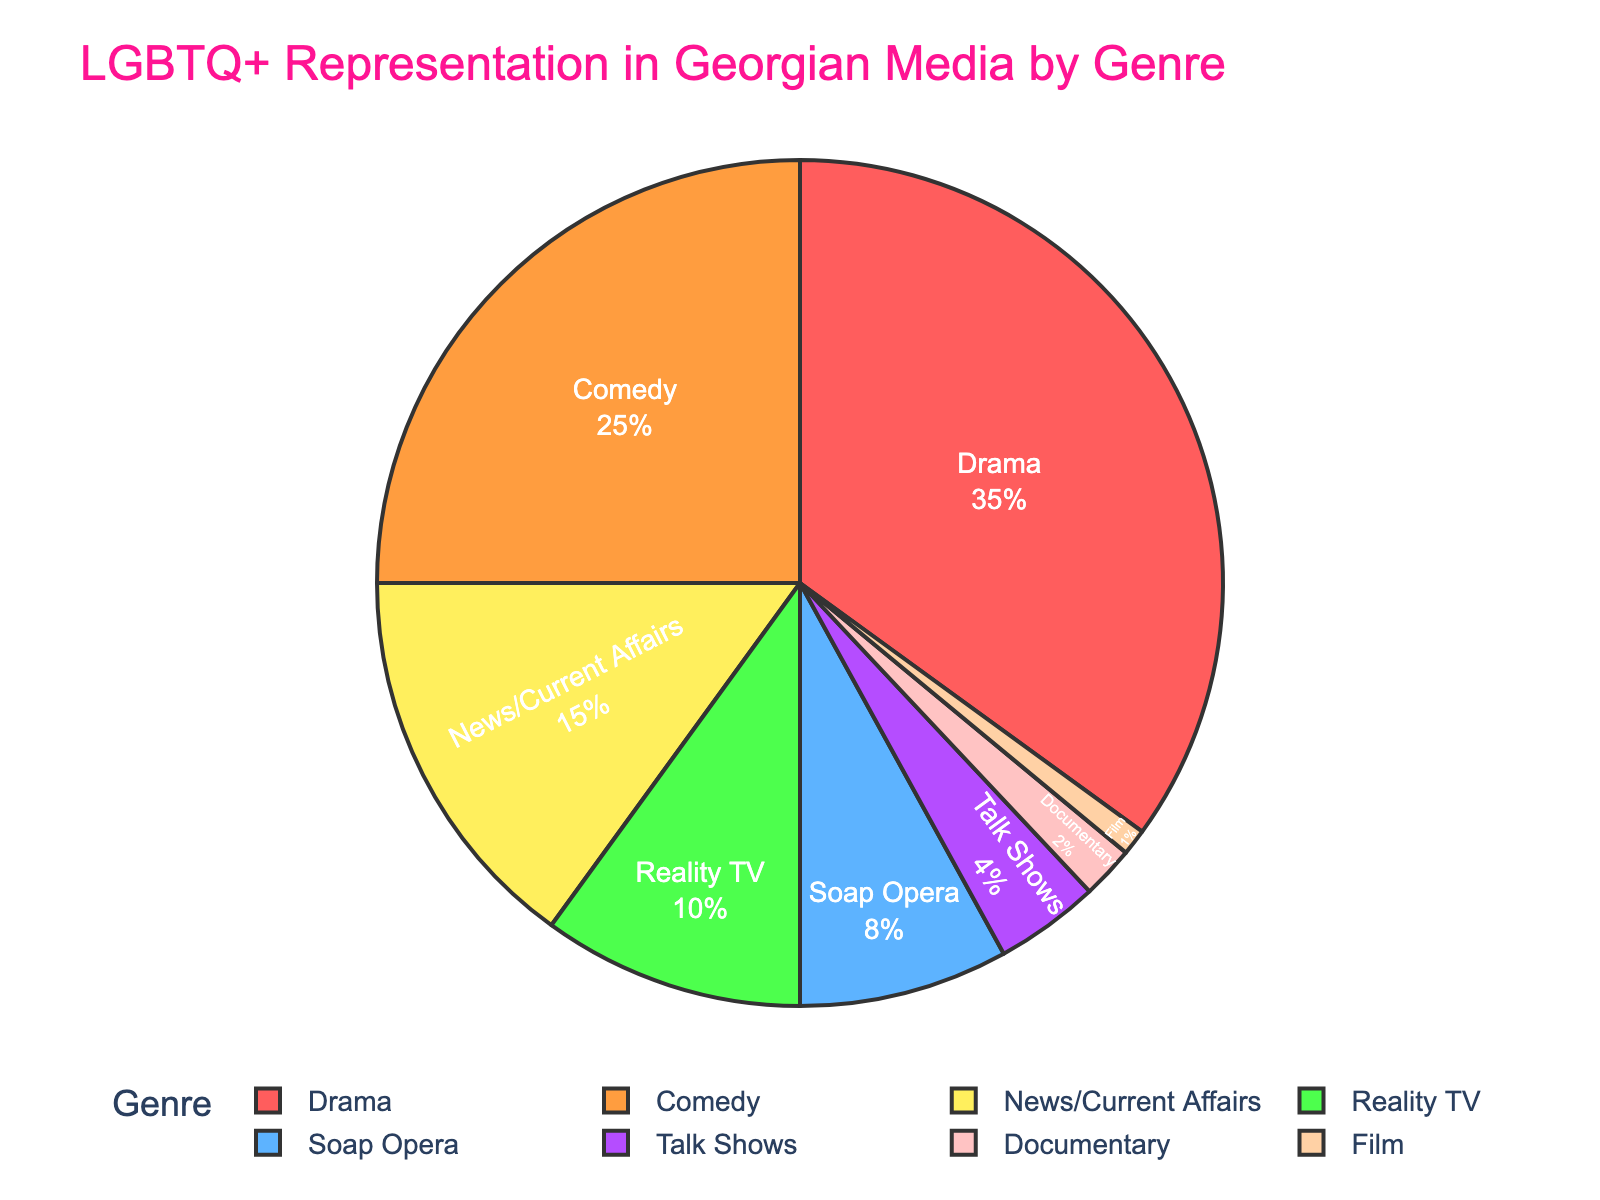What genre has the highest percentage of LGBTQ+ representation in Georgian media? The genre with the highest percentage can be identified by finding the largest segment in the pie chart. From the chart, Drama has the largest slice.
Answer: Drama Which genre has the least representation of LGBTQ+ characters? The least representation can be identified by the smallest segment in the pie chart. From the chart, Film has the smallest slice.
Answer: Film What is the difference in percentage between Drama and Comedy genres? First, find the percentages of Drama (35%) and Comedy (25%). Then, subtract the Comedy percentage from the Drama percentage: 35% - 25% = 10%.
Answer: 10% Do Drama and Comedy together account for more than half of the LGBTQ+ representation in Georgian media? Sum the percentages of Drama (35%) and Comedy (25%): 35% + 25% = 60%. Since 60% is more than 50%, Drama and Comedy together account for more than half.
Answer: Yes How does the LGBTQ+ representation in Reality TV compare to that in Talk Shows? Look at the percentages of Reality TV (10%) and Talk Shows (4%). Reality TV has a higher percentage than Talk Shows.
Answer: Reality TV has more Are there any genres with equal representation percentages? Visually inspect the pie chart to check if any two segments have the same size. No two segments have equal areas, indicating no genres have equal percentages.
Answer: No What proportion of LGBTQ+ representation is in News/Current Affairs? The pie chart shows News/Current Affairs having a percentage of 15%.
Answer: 15% How many genres have greater than 10% representation? Identify the genres with more than 10% representation: Drama (35%), Comedy (25%), and News/Current Affairs (15%). There are three such genres.
Answer: 3 What is the combined representation of Soap Opera and Talk Shows? Sum the percentages of Soap Opera (8%) and Talk Shows (4%): 8% + 4% = 12%.
Answer: 12% Which genres are represented using the color green? Visually check the color slices and find that the segment for Reality TV is green.
Answer: Reality TV 